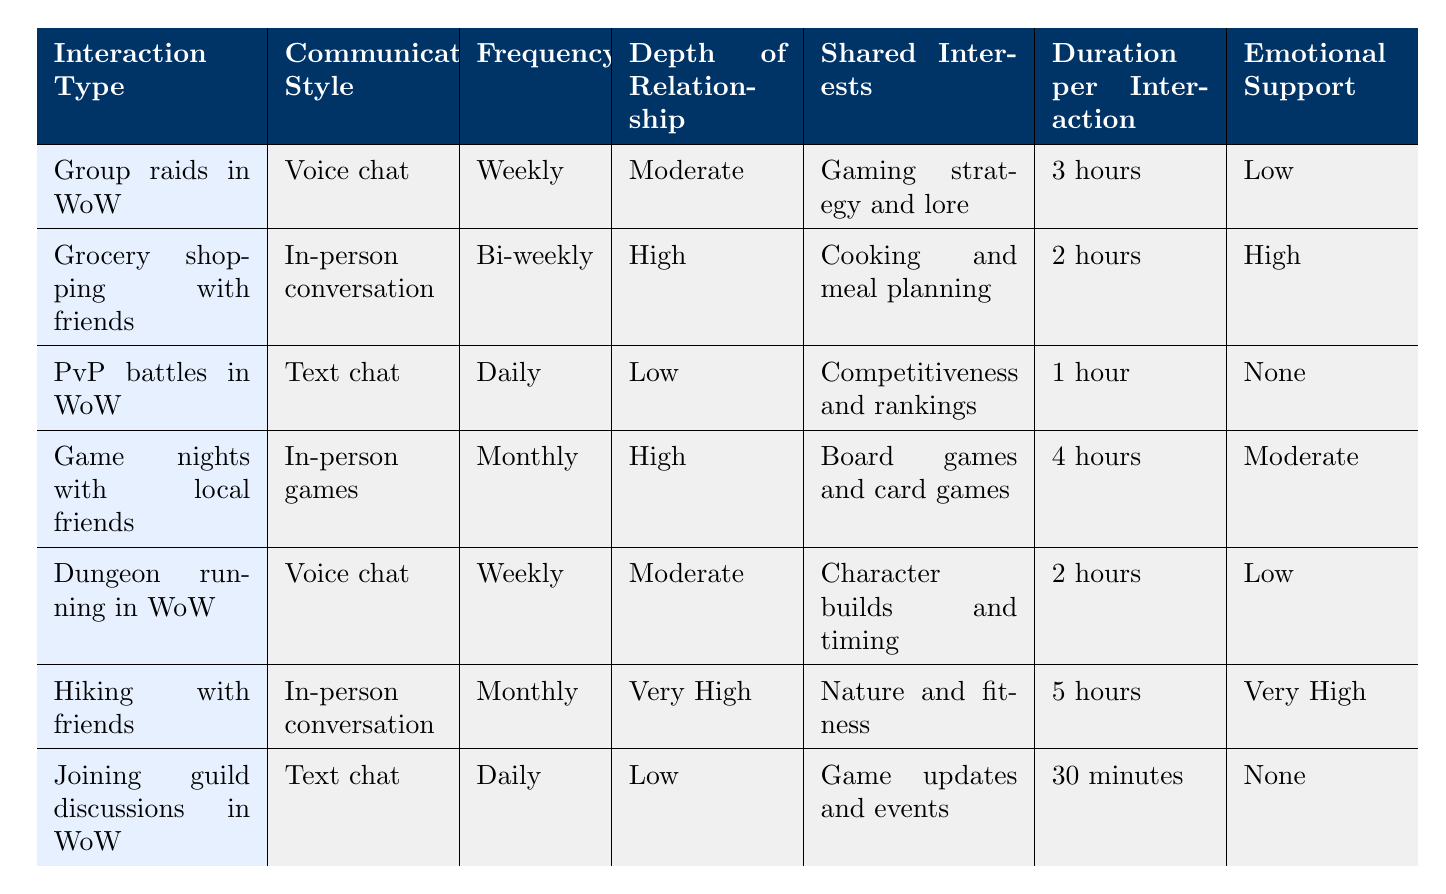What is the depth of relationship for 'Hiking with friends'? The depth of relationship for 'Hiking with friends' can be found directly in the table under the 'Depth of Relationship' column. The corresponding value is 'Very High'.
Answer: Very High How often do players engage in 'PvP battles in World of Warcraft'? The frequency of 'PvP battles in World of Warcraft' is listed in the table under the 'Frequency' column. It states that this activity takes place 'Daily'.
Answer: Daily Which interaction type has the longest duration per interaction? To find out the longest duration, observe the 'Duration per Interaction' column for each interaction type and compare the values. The longest duration is '5 hours' which corresponds to 'Hiking with friends'.
Answer: 5 hours What is the average duration per interaction for the real-life activities? The real-life activities include 'Grocery shopping with friends', 'Game nights with local friends', and 'Hiking with friends'. Their respective durations are 2 hours, 4 hours, and 5 hours. Summing these gives 2 + 4 + 5 = 11 hours. Dividing by the three activities gives an average of 11/3 = 3.67 hours.
Answer: 3.67 hours Is emotional support provided in 'Joining guild discussions in World of Warcraft'? The table indicates that the emotional support for 'Joining guild discussions in World of Warcraft' is 'None'. Therefore, the answer is no.
Answer: No Which interaction types offer high emotional support? To determine which interaction types offer high emotional support, we look for the 'High' or 'Very High' values in the 'Emotional Support' column. The activities that fall under these classifications are 'Grocery shopping with friends' and 'Hiking with friends'.
Answer: Grocery shopping with friends, Hiking with friends What can be inferred about the relationship depth in gaming compared to real life? By examining the 'Depth of Relationship' values, we see that gaming interactions like 'PvP battles' and 'Joining guild discussions' have 'Low' depth, while real-life interactions like 'Grocery shopping' and 'Hiking' have 'High' and 'Very High', respectively. This suggests that real-life interactions tend to foster deeper relationships compared to gaming interactions.
Answer: Real-life interactions foster deeper relationships compared to gaming interactions 